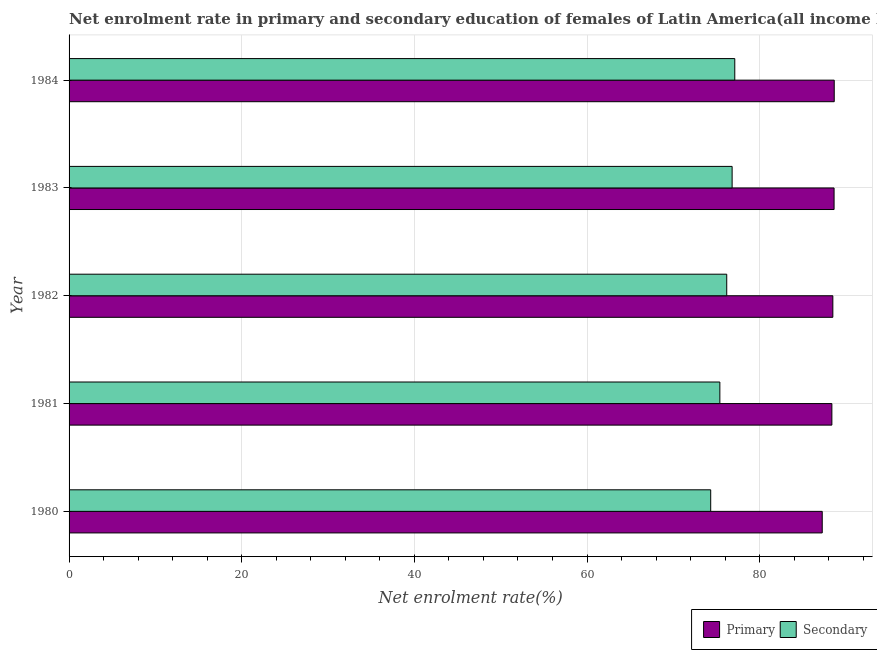How many different coloured bars are there?
Your answer should be very brief. 2. Are the number of bars on each tick of the Y-axis equal?
Your answer should be very brief. Yes. In how many cases, is the number of bars for a given year not equal to the number of legend labels?
Offer a terse response. 0. What is the enrollment rate in secondary education in 1981?
Offer a very short reply. 75.38. Across all years, what is the maximum enrollment rate in primary education?
Your response must be concise. 88.63. Across all years, what is the minimum enrollment rate in primary education?
Your answer should be compact. 87.24. What is the total enrollment rate in secondary education in the graph?
Provide a succinct answer. 379.8. What is the difference between the enrollment rate in primary education in 1980 and that in 1982?
Give a very brief answer. -1.23. What is the difference between the enrollment rate in primary education in 1982 and the enrollment rate in secondary education in 1983?
Make the answer very short. 11.67. What is the average enrollment rate in primary education per year?
Keep it short and to the point. 88.26. In the year 1981, what is the difference between the enrollment rate in primary education and enrollment rate in secondary education?
Offer a terse response. 12.97. What is the ratio of the enrollment rate in primary education in 1981 to that in 1983?
Make the answer very short. 1. Is the enrollment rate in primary education in 1982 less than that in 1984?
Provide a short and direct response. Yes. What is the difference between the highest and the second highest enrollment rate in primary education?
Your answer should be compact. 0.02. What is the difference between the highest and the lowest enrollment rate in primary education?
Offer a very short reply. 1.39. In how many years, is the enrollment rate in secondary education greater than the average enrollment rate in secondary education taken over all years?
Your answer should be very brief. 3. What does the 2nd bar from the top in 1983 represents?
Make the answer very short. Primary. What does the 1st bar from the bottom in 1984 represents?
Provide a succinct answer. Primary. How many bars are there?
Give a very brief answer. 10. How many years are there in the graph?
Ensure brevity in your answer.  5. Are the values on the major ticks of X-axis written in scientific E-notation?
Provide a succinct answer. No. How many legend labels are there?
Offer a very short reply. 2. How are the legend labels stacked?
Provide a short and direct response. Horizontal. What is the title of the graph?
Keep it short and to the point. Net enrolment rate in primary and secondary education of females of Latin America(all income levels). What is the label or title of the X-axis?
Keep it short and to the point. Net enrolment rate(%). What is the Net enrolment rate(%) in Primary in 1980?
Ensure brevity in your answer.  87.24. What is the Net enrolment rate(%) in Secondary in 1980?
Keep it short and to the point. 74.32. What is the Net enrolment rate(%) of Primary in 1981?
Your response must be concise. 88.36. What is the Net enrolment rate(%) of Secondary in 1981?
Give a very brief answer. 75.38. What is the Net enrolment rate(%) in Primary in 1982?
Make the answer very short. 88.47. What is the Net enrolment rate(%) of Secondary in 1982?
Make the answer very short. 76.18. What is the Net enrolment rate(%) of Primary in 1983?
Offer a terse response. 88.62. What is the Net enrolment rate(%) in Secondary in 1983?
Ensure brevity in your answer.  76.8. What is the Net enrolment rate(%) of Primary in 1984?
Your answer should be very brief. 88.63. What is the Net enrolment rate(%) in Secondary in 1984?
Provide a succinct answer. 77.11. Across all years, what is the maximum Net enrolment rate(%) of Primary?
Make the answer very short. 88.63. Across all years, what is the maximum Net enrolment rate(%) of Secondary?
Ensure brevity in your answer.  77.11. Across all years, what is the minimum Net enrolment rate(%) in Primary?
Your response must be concise. 87.24. Across all years, what is the minimum Net enrolment rate(%) in Secondary?
Provide a short and direct response. 74.32. What is the total Net enrolment rate(%) of Primary in the graph?
Offer a terse response. 441.32. What is the total Net enrolment rate(%) of Secondary in the graph?
Offer a terse response. 379.8. What is the difference between the Net enrolment rate(%) of Primary in 1980 and that in 1981?
Give a very brief answer. -1.12. What is the difference between the Net enrolment rate(%) in Secondary in 1980 and that in 1981?
Your answer should be very brief. -1.06. What is the difference between the Net enrolment rate(%) of Primary in 1980 and that in 1982?
Offer a terse response. -1.23. What is the difference between the Net enrolment rate(%) of Secondary in 1980 and that in 1982?
Your response must be concise. -1.86. What is the difference between the Net enrolment rate(%) of Primary in 1980 and that in 1983?
Your answer should be compact. -1.37. What is the difference between the Net enrolment rate(%) in Secondary in 1980 and that in 1983?
Offer a terse response. -2.48. What is the difference between the Net enrolment rate(%) of Primary in 1980 and that in 1984?
Your answer should be very brief. -1.39. What is the difference between the Net enrolment rate(%) of Secondary in 1980 and that in 1984?
Ensure brevity in your answer.  -2.79. What is the difference between the Net enrolment rate(%) in Primary in 1981 and that in 1982?
Your response must be concise. -0.11. What is the difference between the Net enrolment rate(%) in Secondary in 1981 and that in 1982?
Provide a succinct answer. -0.8. What is the difference between the Net enrolment rate(%) of Primary in 1981 and that in 1983?
Provide a short and direct response. -0.26. What is the difference between the Net enrolment rate(%) in Secondary in 1981 and that in 1983?
Offer a very short reply. -1.42. What is the difference between the Net enrolment rate(%) of Primary in 1981 and that in 1984?
Your answer should be very brief. -0.27. What is the difference between the Net enrolment rate(%) in Secondary in 1981 and that in 1984?
Provide a short and direct response. -1.73. What is the difference between the Net enrolment rate(%) in Primary in 1982 and that in 1983?
Give a very brief answer. -0.14. What is the difference between the Net enrolment rate(%) in Secondary in 1982 and that in 1983?
Your answer should be very brief. -0.63. What is the difference between the Net enrolment rate(%) in Primary in 1982 and that in 1984?
Keep it short and to the point. -0.16. What is the difference between the Net enrolment rate(%) of Secondary in 1982 and that in 1984?
Your answer should be compact. -0.93. What is the difference between the Net enrolment rate(%) of Primary in 1983 and that in 1984?
Offer a terse response. -0.02. What is the difference between the Net enrolment rate(%) in Secondary in 1983 and that in 1984?
Give a very brief answer. -0.31. What is the difference between the Net enrolment rate(%) of Primary in 1980 and the Net enrolment rate(%) of Secondary in 1981?
Offer a terse response. 11.86. What is the difference between the Net enrolment rate(%) in Primary in 1980 and the Net enrolment rate(%) in Secondary in 1982?
Offer a very short reply. 11.06. What is the difference between the Net enrolment rate(%) of Primary in 1980 and the Net enrolment rate(%) of Secondary in 1983?
Your answer should be compact. 10.44. What is the difference between the Net enrolment rate(%) of Primary in 1980 and the Net enrolment rate(%) of Secondary in 1984?
Your response must be concise. 10.13. What is the difference between the Net enrolment rate(%) of Primary in 1981 and the Net enrolment rate(%) of Secondary in 1982?
Offer a terse response. 12.18. What is the difference between the Net enrolment rate(%) of Primary in 1981 and the Net enrolment rate(%) of Secondary in 1983?
Provide a short and direct response. 11.55. What is the difference between the Net enrolment rate(%) of Primary in 1981 and the Net enrolment rate(%) of Secondary in 1984?
Provide a short and direct response. 11.25. What is the difference between the Net enrolment rate(%) of Primary in 1982 and the Net enrolment rate(%) of Secondary in 1983?
Your answer should be compact. 11.67. What is the difference between the Net enrolment rate(%) in Primary in 1982 and the Net enrolment rate(%) in Secondary in 1984?
Provide a short and direct response. 11.36. What is the difference between the Net enrolment rate(%) of Primary in 1983 and the Net enrolment rate(%) of Secondary in 1984?
Offer a very short reply. 11.5. What is the average Net enrolment rate(%) of Primary per year?
Give a very brief answer. 88.26. What is the average Net enrolment rate(%) in Secondary per year?
Make the answer very short. 75.96. In the year 1980, what is the difference between the Net enrolment rate(%) of Primary and Net enrolment rate(%) of Secondary?
Offer a terse response. 12.92. In the year 1981, what is the difference between the Net enrolment rate(%) of Primary and Net enrolment rate(%) of Secondary?
Your response must be concise. 12.98. In the year 1982, what is the difference between the Net enrolment rate(%) of Primary and Net enrolment rate(%) of Secondary?
Make the answer very short. 12.29. In the year 1983, what is the difference between the Net enrolment rate(%) of Primary and Net enrolment rate(%) of Secondary?
Provide a succinct answer. 11.81. In the year 1984, what is the difference between the Net enrolment rate(%) in Primary and Net enrolment rate(%) in Secondary?
Keep it short and to the point. 11.52. What is the ratio of the Net enrolment rate(%) in Primary in 1980 to that in 1981?
Ensure brevity in your answer.  0.99. What is the ratio of the Net enrolment rate(%) of Secondary in 1980 to that in 1981?
Make the answer very short. 0.99. What is the ratio of the Net enrolment rate(%) of Primary in 1980 to that in 1982?
Provide a short and direct response. 0.99. What is the ratio of the Net enrolment rate(%) of Secondary in 1980 to that in 1982?
Your response must be concise. 0.98. What is the ratio of the Net enrolment rate(%) in Primary in 1980 to that in 1983?
Make the answer very short. 0.98. What is the ratio of the Net enrolment rate(%) in Secondary in 1980 to that in 1983?
Make the answer very short. 0.97. What is the ratio of the Net enrolment rate(%) of Primary in 1980 to that in 1984?
Your answer should be compact. 0.98. What is the ratio of the Net enrolment rate(%) in Secondary in 1980 to that in 1984?
Offer a very short reply. 0.96. What is the ratio of the Net enrolment rate(%) in Primary in 1981 to that in 1982?
Provide a short and direct response. 1. What is the ratio of the Net enrolment rate(%) in Secondary in 1981 to that in 1982?
Your answer should be very brief. 0.99. What is the ratio of the Net enrolment rate(%) of Secondary in 1981 to that in 1983?
Offer a very short reply. 0.98. What is the ratio of the Net enrolment rate(%) of Primary in 1981 to that in 1984?
Provide a succinct answer. 1. What is the ratio of the Net enrolment rate(%) in Secondary in 1981 to that in 1984?
Make the answer very short. 0.98. What is the ratio of the Net enrolment rate(%) in Primary in 1982 to that in 1983?
Your response must be concise. 1. What is the ratio of the Net enrolment rate(%) in Primary in 1982 to that in 1984?
Your response must be concise. 1. What is the ratio of the Net enrolment rate(%) in Secondary in 1982 to that in 1984?
Offer a very short reply. 0.99. What is the ratio of the Net enrolment rate(%) in Primary in 1983 to that in 1984?
Offer a terse response. 1. What is the ratio of the Net enrolment rate(%) in Secondary in 1983 to that in 1984?
Give a very brief answer. 1. What is the difference between the highest and the second highest Net enrolment rate(%) in Primary?
Your answer should be very brief. 0.02. What is the difference between the highest and the second highest Net enrolment rate(%) in Secondary?
Ensure brevity in your answer.  0.31. What is the difference between the highest and the lowest Net enrolment rate(%) of Primary?
Ensure brevity in your answer.  1.39. What is the difference between the highest and the lowest Net enrolment rate(%) in Secondary?
Offer a terse response. 2.79. 